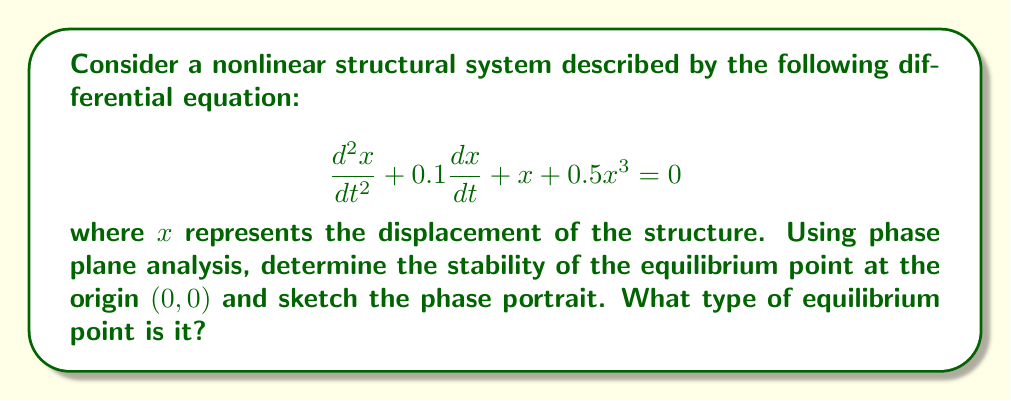Provide a solution to this math problem. 1. First, let's rewrite the second-order differential equation as a system of first-order equations:

   Let $y = \frac{dx}{dt}$, then:
   $$\frac{dx}{dt} = y$$
   $$\frac{dy}{dt} = -0.1y - x - 0.5x^3$$

2. The equilibrium points are found by setting $\frac{dx}{dt} = \frac{dy}{dt} = 0$:
   $$y = 0$$
   $$-x - 0.5x^3 = 0$$
   
   Solving these equations, we find that $(0,0)$ is the only equilibrium point.

3. To analyze the stability at $(0,0)$, we need to linearize the system around this point. The Jacobian matrix at $(0,0)$ is:

   $$J = \begin{bmatrix}
   \frac{\partial}{\partial x}(y) & \frac{\partial}{\partial y}(y) \\
   \frac{\partial}{\partial x}(-0.1y - x - 0.5x^3) & \frac{\partial}{\partial y}(-0.1y - x - 0.5x^3)
   \end{bmatrix}_{(0,0)}
   = \begin{bmatrix}
   0 & 1 \\
   -1 & -0.1
   \end{bmatrix}$$

4. The eigenvalues of J are found by solving the characteristic equation:
   $$\det(J - \lambda I) = \lambda^2 + 0.1\lambda + 1 = 0$$

   The solutions are: $\lambda = -0.05 \pm 0.999i$

5. Since the real parts of both eigenvalues are negative, the equilibrium point $(0,0)$ is asymptotically stable.

6. The phase portrait will show spirals converging to the origin, indicating a stable focus.

[asy]
import graph;
size(200);
xaxis("x",-2,2,Arrow);
yaxis("y",-2,2,Arrow);

real f(real x, real y) { return y; }
real g(real x, real y) { return -0.1*y - x - 0.5*x^3; }

add(vectorfield((f,g),(-2,-2),(2,2),0.15,blue));

draw((-2,-2)--(2,2),dashed);
draw((-2,2)--(2,-2),dashed);

dot((0,0));
label("(0,0)",(0,0),SE);
[/asy]
Answer: The origin $(0,0)$ is an asymptotically stable focus. 